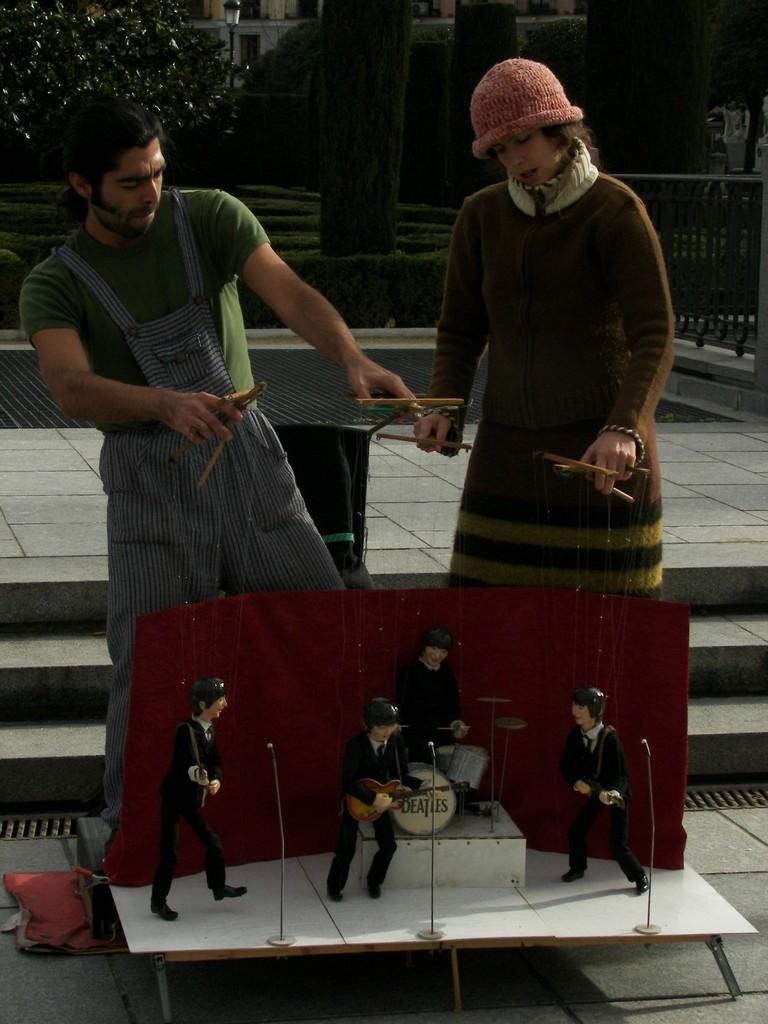Could you give a brief overview of what you see in this image? In this image I see a man and a woman who are holding sticks and I see that there are ropes tied to it and those ropes are tied to these puppets and I see the miniature set of drums, guitars and mics and I see the steps and the path. In the background I see the plants, bushes and the fence over here and I see the light pole over here and I see that this woman is wearing a cap. 